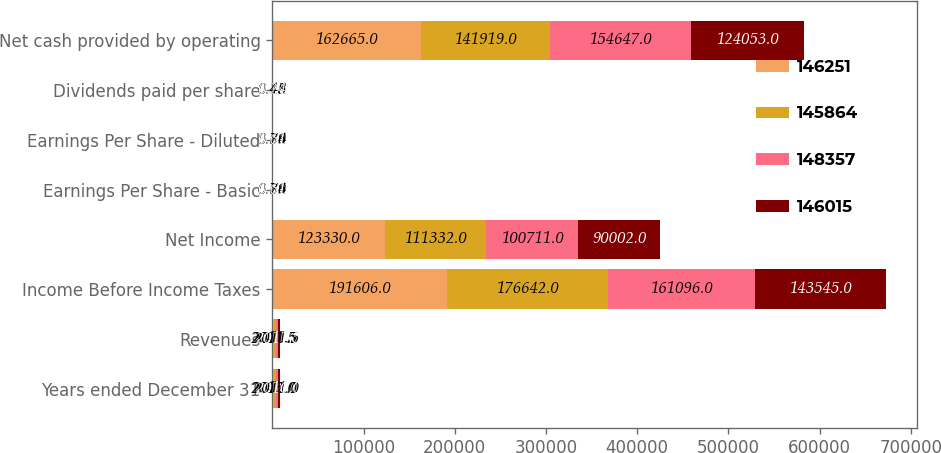<chart> <loc_0><loc_0><loc_500><loc_500><stacked_bar_chart><ecel><fcel>Years ended December 31<fcel>Revenues<fcel>Income Before Income Taxes<fcel>Net Income<fcel>Earnings Per Share - Basic<fcel>Earnings Per Share - Diluted<fcel>Dividends paid per share<fcel>Net cash provided by operating<nl><fcel>146251<fcel>2013<fcel>2011.5<fcel>191606<fcel>123330<fcel>0.84<fcel>0.84<fcel>0.45<fcel>162665<nl><fcel>145864<fcel>2012<fcel>2011.5<fcel>176642<fcel>111332<fcel>0.76<fcel>0.76<fcel>0.44<fcel>141919<nl><fcel>148357<fcel>2011<fcel>2011.5<fcel>161096<fcel>100711<fcel>0.69<fcel>0.69<fcel>0.28<fcel>154647<nl><fcel>146015<fcel>2010<fcel>2011.5<fcel>143545<fcel>90002<fcel>0.61<fcel>0.61<fcel>0.24<fcel>124053<nl></chart> 